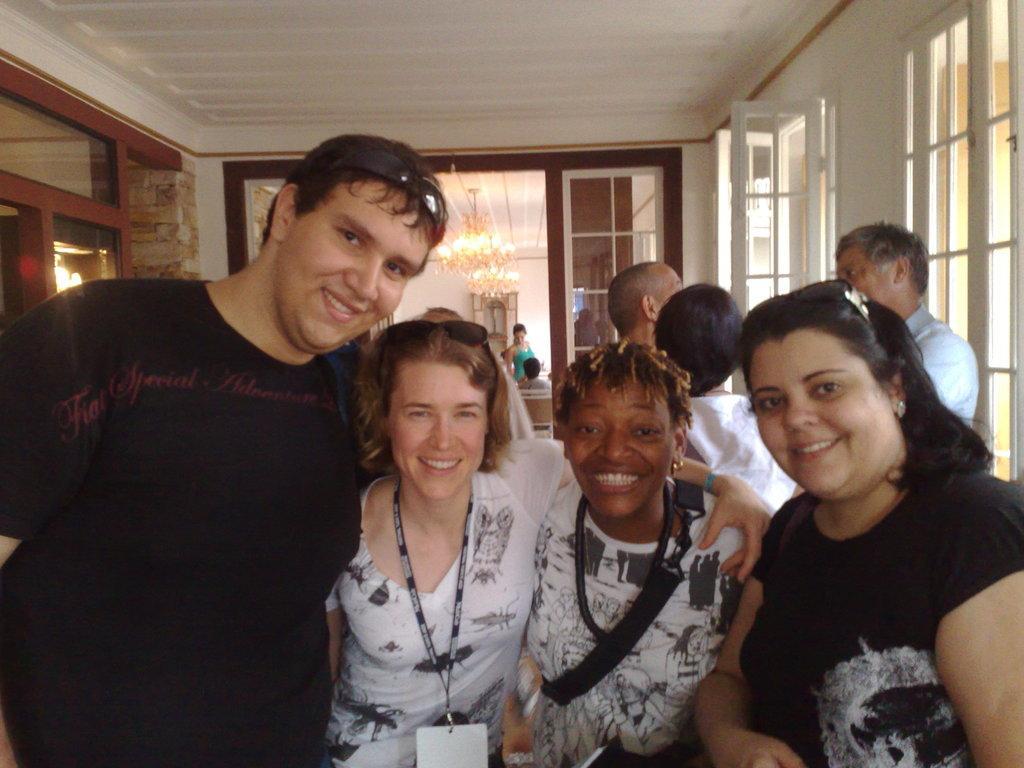In one or two sentences, can you explain what this image depicts? There are people and these people are smiling. We can see windows. In the background we can see people, chandeliers, wall, chair and lights. 